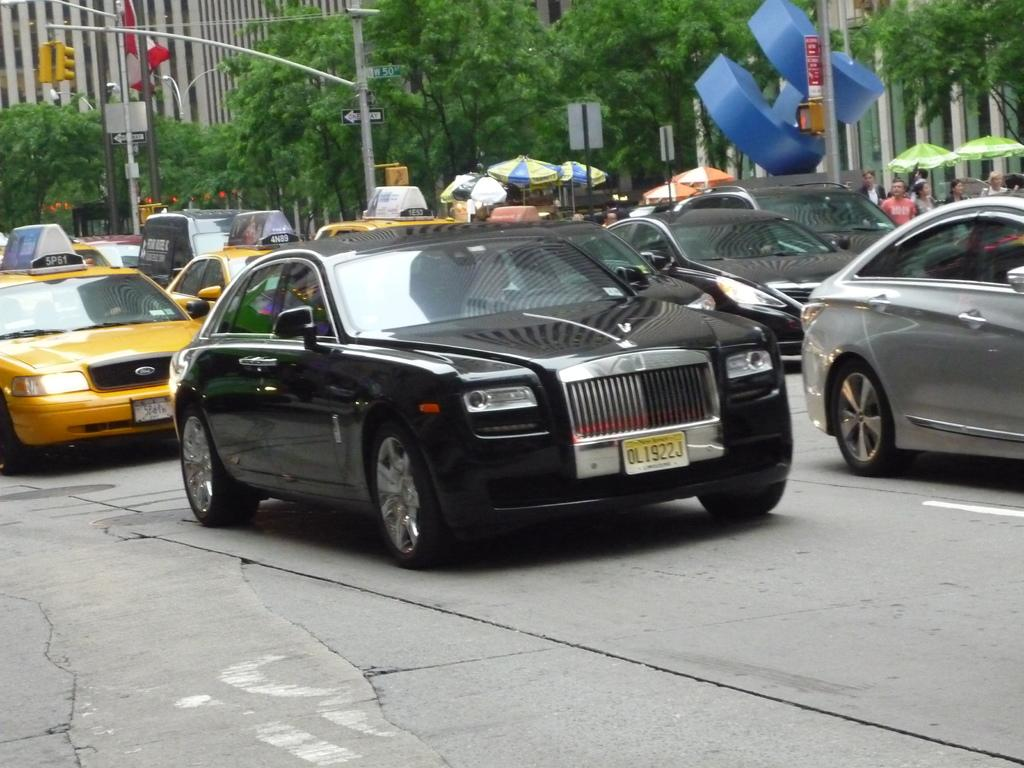<image>
Write a terse but informative summary of the picture. a car in traffic with a licence plate of ol1922j 